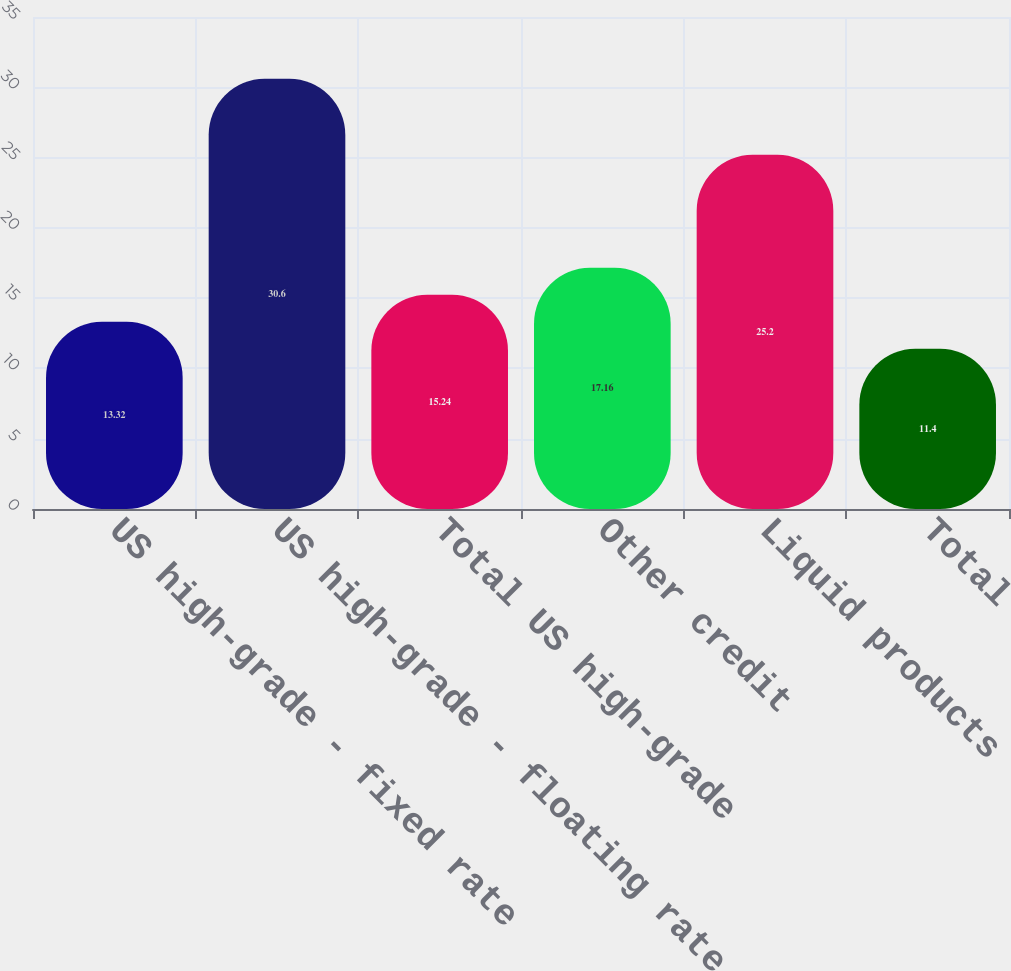Convert chart to OTSL. <chart><loc_0><loc_0><loc_500><loc_500><bar_chart><fcel>US high-grade - fixed rate<fcel>US high-grade - floating rate<fcel>Total US high-grade<fcel>Other credit<fcel>Liquid products<fcel>Total<nl><fcel>13.32<fcel>30.6<fcel>15.24<fcel>17.16<fcel>25.2<fcel>11.4<nl></chart> 